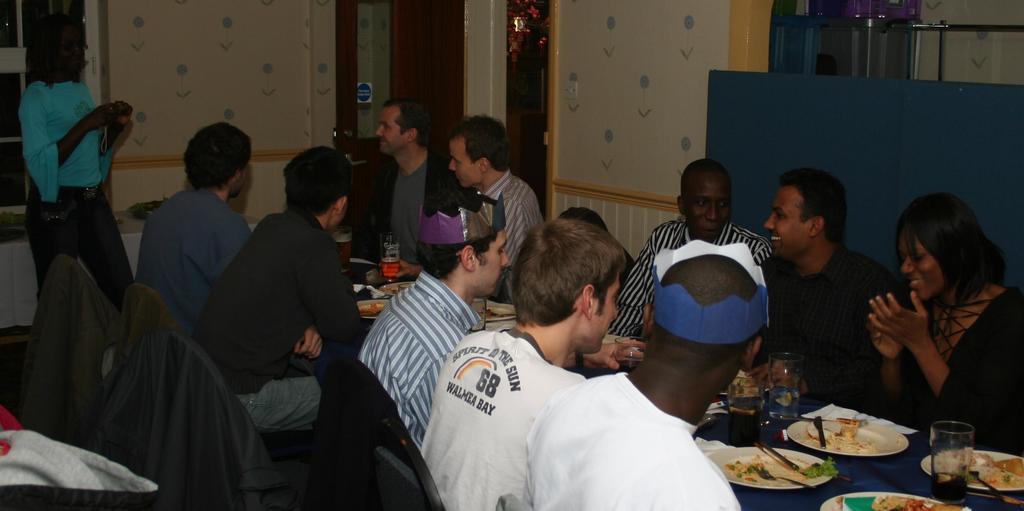What team number is the sportsman wearing?
Provide a succinct answer. 68. Is the man the spirit of the sun?
Your answer should be very brief. Yes. 